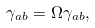Convert formula to latex. <formula><loc_0><loc_0><loc_500><loc_500>\gamma _ { a b } = \Omega \gamma _ { a b } ,</formula> 